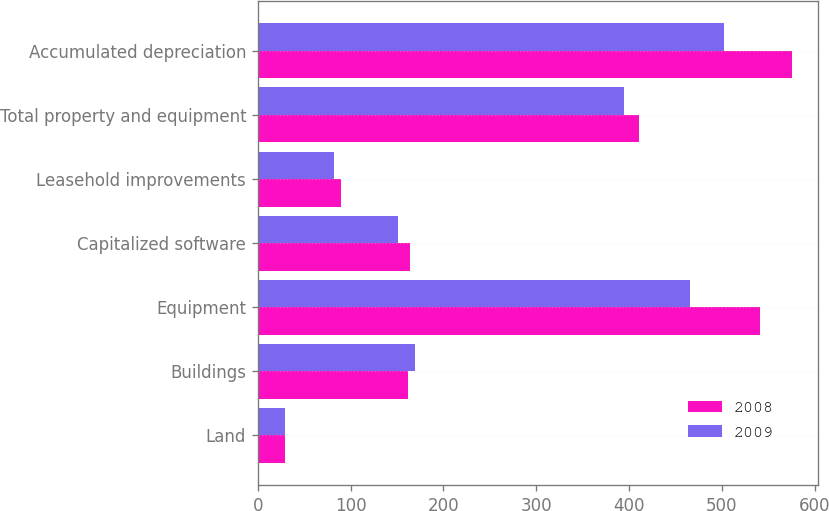Convert chart to OTSL. <chart><loc_0><loc_0><loc_500><loc_500><stacked_bar_chart><ecel><fcel>Land<fcel>Buildings<fcel>Equipment<fcel>Capitalized software<fcel>Leasehold improvements<fcel>Total property and equipment<fcel>Accumulated depreciation<nl><fcel>2008<fcel>29<fcel>162<fcel>541<fcel>164<fcel>90<fcel>411<fcel>575<nl><fcel>2009<fcel>29<fcel>169<fcel>466<fcel>151<fcel>82<fcel>395<fcel>502<nl></chart> 